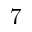<formula> <loc_0><loc_0><loc_500><loc_500>7</formula> 